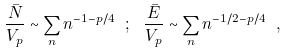<formula> <loc_0><loc_0><loc_500><loc_500>\frac { \bar { N } } { V _ { p } } \sim \sum _ { n } n ^ { - 1 - p / 4 } \ ; \ \frac { \bar { E } } { V _ { p } } \sim \sum _ { n } n ^ { - 1 / 2 - p / 4 } \ ,</formula> 